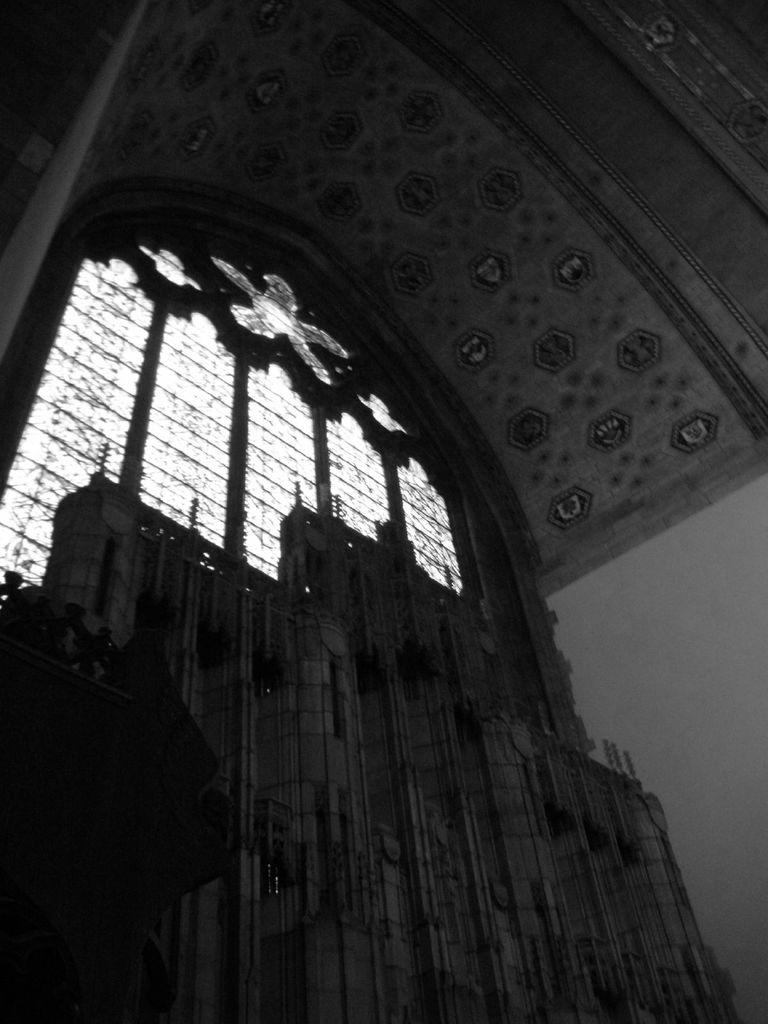What is located in the center of the image? There is a wall in the center of the image. What feature can be seen on the wall? There are windows in the wall. What is above the wall in the image? There is a ceiling at the top of the image. What is on the right side of the image? There is a wall on the right side of the image. How many rabbits are visible in the image? There are no rabbits present in the image. What type of company is mentioned in the image? There is no mention of a company in the image. 